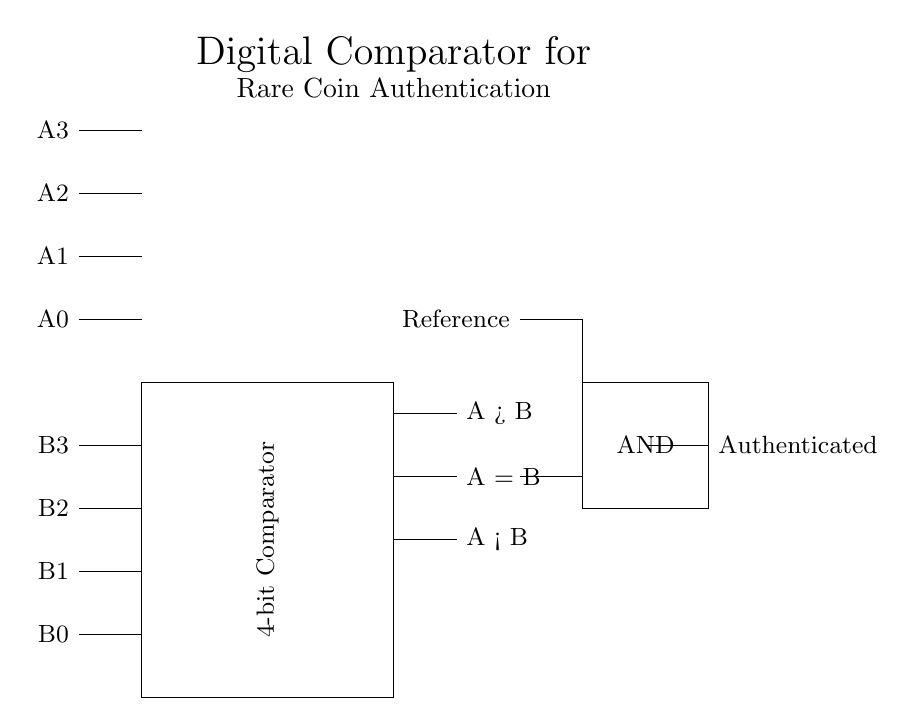What is the function of the rectangle in the circuit? The rectangle represents a 4-bit comparator that compares two 4-bit binary numbers A and B. This component outputs three signals indicating whether A is greater than, equal to, or less than B.
Answer: 4-bit Comparator How many input lines does the circuit have? The circuit has eight input lines, consisting of four from A (A3, A2, A1, A0) and four from B (B3, B2, B1, B0).
Answer: Eight What type of logic gate is used for authentication? The authentication logic is implemented using an AND gate, as indicated by the rectangle labeled "AND" in the circuit.
Answer: AND What do the three output lines represent? The three output lines indicate the comparison results: A > B, A = B, and A < B, providing information about the relative values of the inputs.
Answer: Comparison results What must be true for the output to indicate "Authenticated"? For the output to be "Authenticated", the comparison result A must equal B, which is determined by the output signal A = B connecting to the AND gate.
Answer: A must equal B 